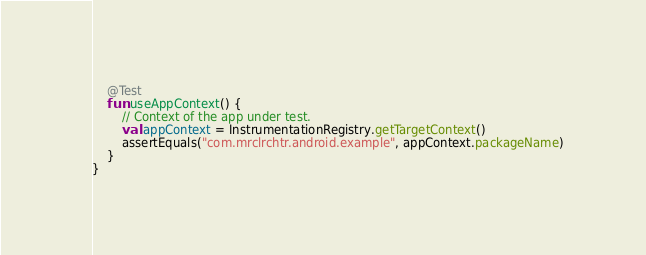<code> <loc_0><loc_0><loc_500><loc_500><_Kotlin_>    @Test
    fun useAppContext() {
        // Context of the app under test.
        val appContext = InstrumentationRegistry.getTargetContext()
        assertEquals("com.mrclrchtr.android.example", appContext.packageName)
    }
}
</code> 